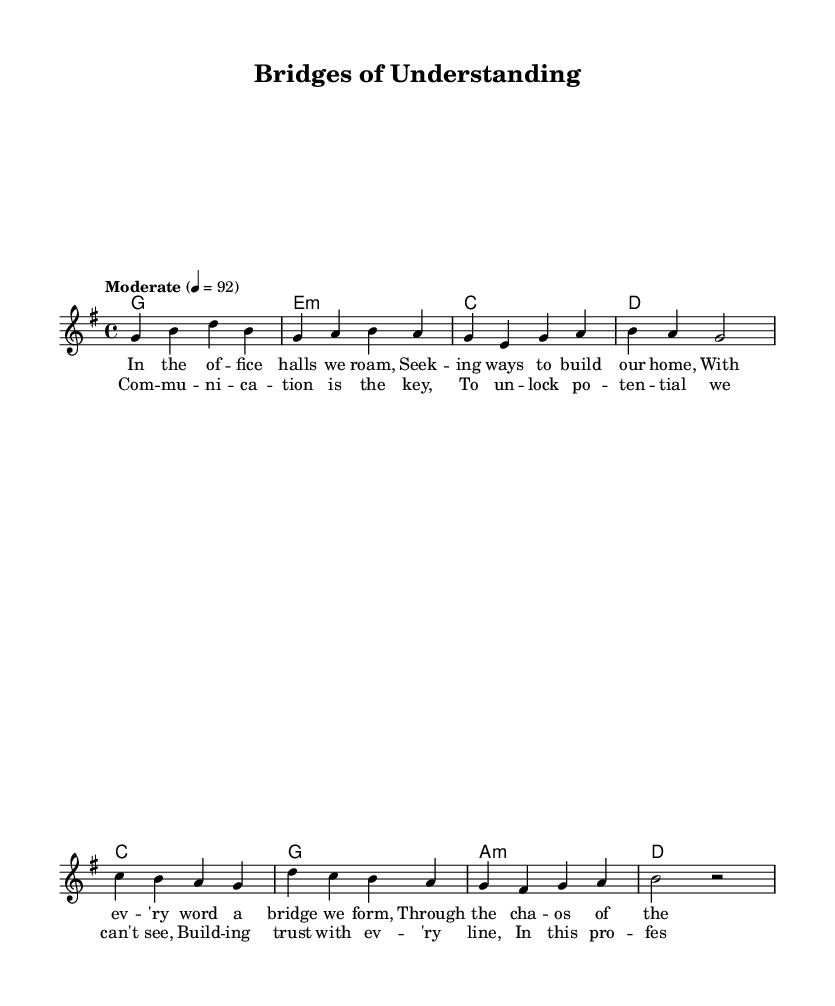What is the key signature of this music? The key signature indicates G major, which has one sharp (F#).
Answer: G major What is the time signature of this music? The time signature is displayed as 4/4, which means there are four beats per measure and the quarter note gets the beat.
Answer: 4/4 What is the tempo marking for this piece? The tempo is indicated as moderate at quarter note equals 92 beats per minute, suggesting a moderately paced performance.
Answer: Moderate How many measures are in the verse section? Counting the measures in the verse, there are four measures indicated before moving to the chorus.
Answer: 4 What is the first chord of the piece? The first chord shown at the beginning of the verse is G major, which is represented by the letter G and is played for one whole note.
Answer: G What lyrical theme is explored in the chorus? The chorus focuses on the importance of communication in building relationships and trust within the professional environment, highlighted through the lyrics.
Answer: Communication Which chord follows A minor in the chorus? After A minor, the next chord in the chorus is D major, maintaining the harmonic progression of the music.
Answer: D 